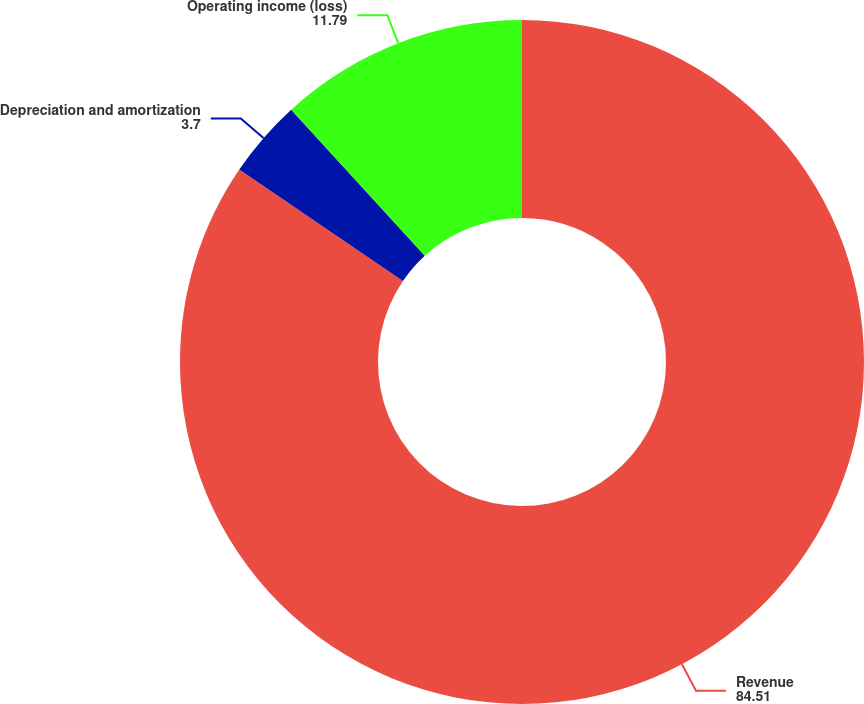Convert chart to OTSL. <chart><loc_0><loc_0><loc_500><loc_500><pie_chart><fcel>Revenue<fcel>Depreciation and amortization<fcel>Operating income (loss)<nl><fcel>84.51%<fcel>3.7%<fcel>11.79%<nl></chart> 